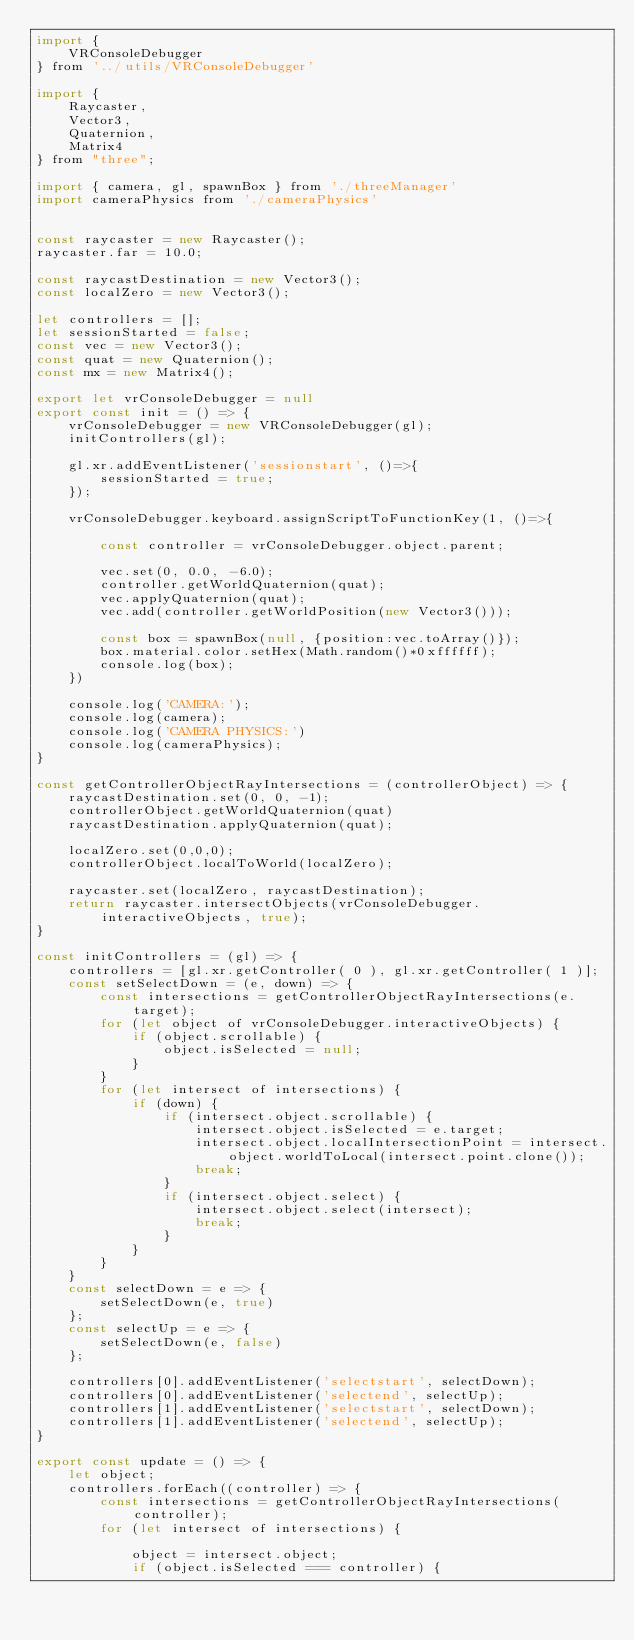Convert code to text. <code><loc_0><loc_0><loc_500><loc_500><_JavaScript_>import {
    VRConsoleDebugger
} from '../utils/VRConsoleDebugger'

import {
    Raycaster,
    Vector3,
    Quaternion,
    Matrix4
} from "three";

import { camera, gl, spawnBox } from './threeManager'
import cameraPhysics from './cameraPhysics'


const raycaster = new Raycaster();
raycaster.far = 10.0;

const raycastDestination = new Vector3();
const localZero = new Vector3();

let controllers = [];
let sessionStarted = false;
const vec = new Vector3();
const quat = new Quaternion();
const mx = new Matrix4();

export let vrConsoleDebugger = null
export const init = () => {
    vrConsoleDebugger = new VRConsoleDebugger(gl);
    initControllers(gl);

    gl.xr.addEventListener('sessionstart', ()=>{
        sessionStarted = true;
    });

    vrConsoleDebugger.keyboard.assignScriptToFunctionKey(1, ()=>{

        const controller = vrConsoleDebugger.object.parent;

        vec.set(0, 0.0, -6.0);
        controller.getWorldQuaternion(quat);
        vec.applyQuaternion(quat);
        vec.add(controller.getWorldPosition(new Vector3()));

        const box = spawnBox(null, {position:vec.toArray()});
        box.material.color.setHex(Math.random()*0xffffff);
        console.log(box);
    })

    console.log('CAMERA:');
    console.log(camera);
    console.log('CAMERA PHYSICS:')
    console.log(cameraPhysics);
}

const getControllerObjectRayIntersections = (controllerObject) => {
    raycastDestination.set(0, 0, -1);
    controllerObject.getWorldQuaternion(quat)
    raycastDestination.applyQuaternion(quat);

    localZero.set(0,0,0);
    controllerObject.localToWorld(localZero);

    raycaster.set(localZero, raycastDestination);
    return raycaster.intersectObjects(vrConsoleDebugger.interactiveObjects, true);
}

const initControllers = (gl) => {
    controllers = [gl.xr.getController( 0 ), gl.xr.getController( 1 )];
    const setSelectDown = (e, down) => {
        const intersections = getControllerObjectRayIntersections(e.target);
        for (let object of vrConsoleDebugger.interactiveObjects) {
            if (object.scrollable) {
                object.isSelected = null;
            }
        }
        for (let intersect of intersections) {
            if (down) {
                if (intersect.object.scrollable) {
                    intersect.object.isSelected = e.target;
                    intersect.object.localIntersectionPoint = intersect.object.worldToLocal(intersect.point.clone());
                    break;
                }
                if (intersect.object.select) {
                    intersect.object.select(intersect);
                    break;
                }
            }
        }
    }
    const selectDown = e => {
        setSelectDown(e, true)
    };
    const selectUp = e => {
        setSelectDown(e, false)
    };

    controllers[0].addEventListener('selectstart', selectDown);
    controllers[0].addEventListener('selectend', selectUp);
    controllers[1].addEventListener('selectstart', selectDown);
    controllers[1].addEventListener('selectend', selectUp);
}

export const update = () => {
    let object;
    controllers.forEach((controller) => {
        const intersections = getControllerObjectRayIntersections(controller);
        for (let intersect of intersections) {

            object = intersect.object;
            if (object.isSelected === controller) {</code> 